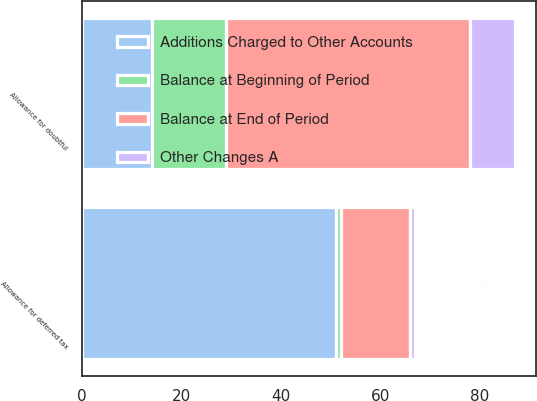Convert chart to OTSL. <chart><loc_0><loc_0><loc_500><loc_500><stacked_bar_chart><ecel><fcel>Allowance for doubtful<fcel>Allowance for deferred tax<nl><fcel>Balance at End of Period<fcel>49<fcel>14<nl><fcel>Other Changes A<fcel>9<fcel>1<nl><fcel>Additions Charged to Other Accounts<fcel>14<fcel>51<nl><fcel>Balance at Beginning of Period<fcel>15<fcel>1<nl></chart> 